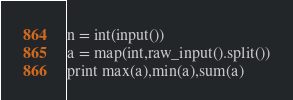<code> <loc_0><loc_0><loc_500><loc_500><_Python_>n = int(input())
a = map(int,raw_input().split())
print max(a),min(a),sum(a)</code> 